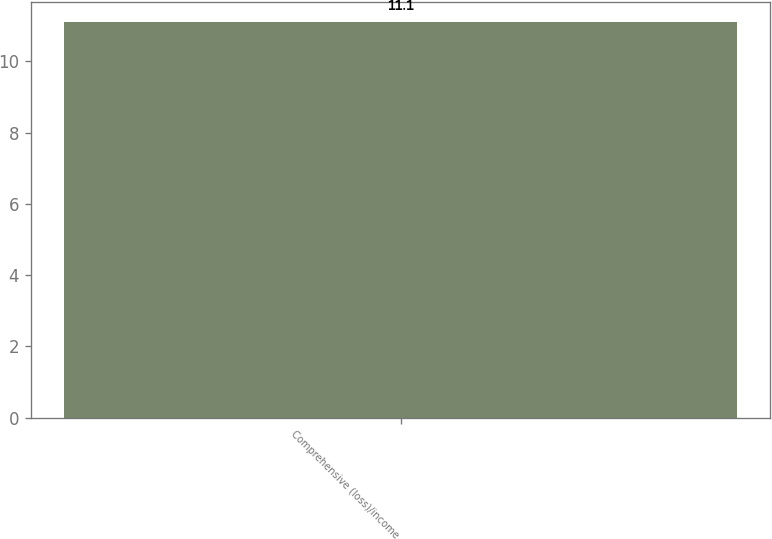Convert chart to OTSL. <chart><loc_0><loc_0><loc_500><loc_500><bar_chart><fcel>Comprehensive (loss)/income<nl><fcel>11.1<nl></chart> 